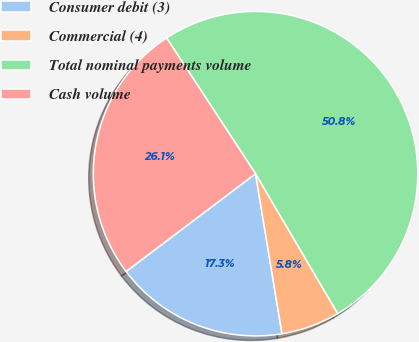Convert chart. <chart><loc_0><loc_0><loc_500><loc_500><pie_chart><fcel>Consumer debit (3)<fcel>Commercial (4)<fcel>Total nominal payments volume<fcel>Cash volume<nl><fcel>17.31%<fcel>5.85%<fcel>50.77%<fcel>26.07%<nl></chart> 